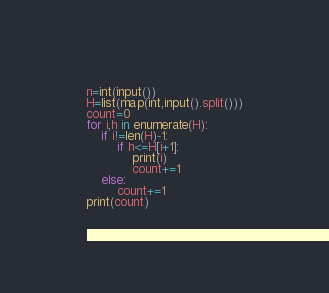Convert code to text. <code><loc_0><loc_0><loc_500><loc_500><_Python_>n=int(input())
H=list(map(int,input().split()))
count=0
for i,h in enumerate(H):
    if i!=len(H)-1:
        if h<=H[i+1]:
            print(i)
            count+=1
    else:
        count+=1
print(count)</code> 